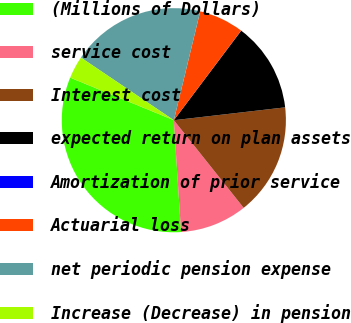<chart> <loc_0><loc_0><loc_500><loc_500><pie_chart><fcel>(Millions of Dollars)<fcel>service cost<fcel>Interest cost<fcel>expected return on plan assets<fcel>Amortization of prior service<fcel>Actuarial loss<fcel>net periodic pension expense<fcel>Increase (Decrease) in pension<nl><fcel>32.22%<fcel>9.68%<fcel>16.12%<fcel>12.9%<fcel>0.02%<fcel>6.46%<fcel>19.34%<fcel>3.24%<nl></chart> 